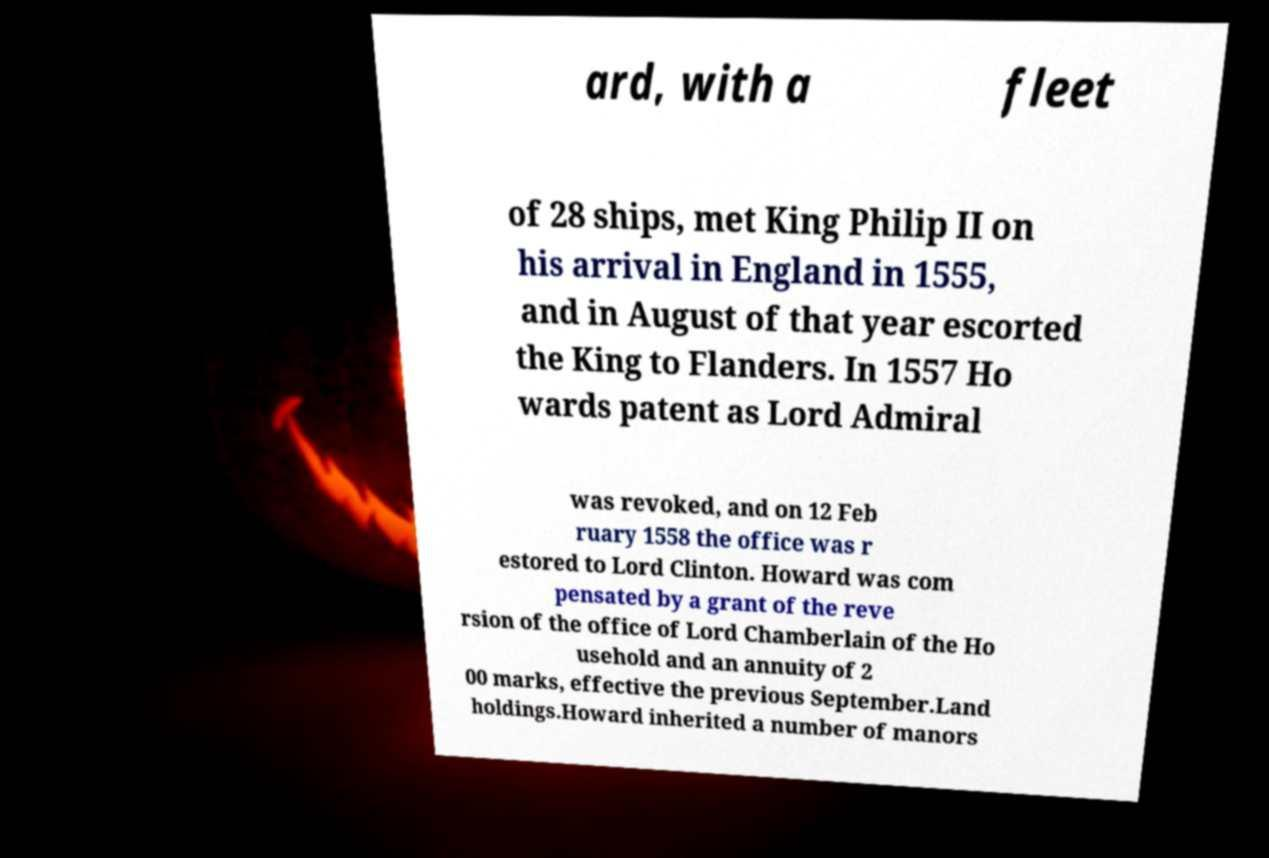Could you assist in decoding the text presented in this image and type it out clearly? ard, with a fleet of 28 ships, met King Philip II on his arrival in England in 1555, and in August of that year escorted the King to Flanders. In 1557 Ho wards patent as Lord Admiral was revoked, and on 12 Feb ruary 1558 the office was r estored to Lord Clinton. Howard was com pensated by a grant of the reve rsion of the office of Lord Chamberlain of the Ho usehold and an annuity of 2 00 marks, effective the previous September.Land holdings.Howard inherited a number of manors 